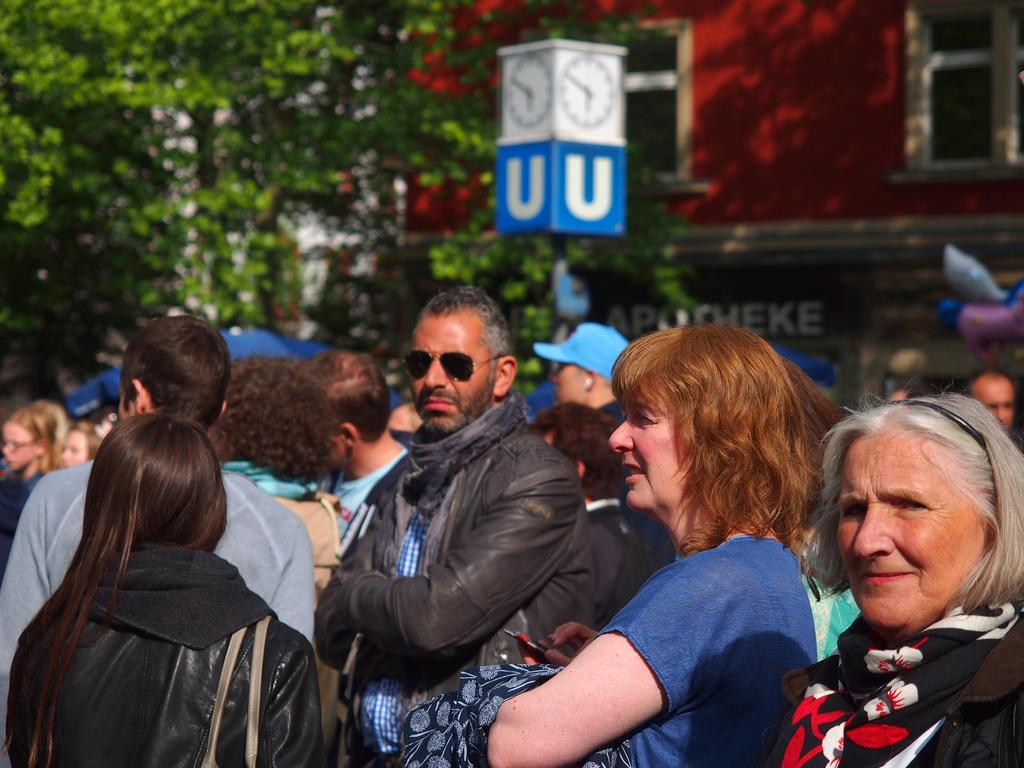What type of clothing item can be seen in the image? There is a bag, a scarf, a jacket, goggles, and a cap visible in the image. What accessory is present in the image? Goggles are present in the image. What type of headwear is in the image? There is a cap in the image. What objects are in the background of the image? There are trees and a building with windows in the background of the image. What structure is visible in the image? There is a pole in the image. What else can be seen in the image? There are clocks in the image. How many people are in the image? There is a group of people standing in the image. What type of vest can be seen on the trees in the background of the image? There are no vests present on the trees in the background of the image. What type of sail is visible on the building in the background of the image? There are no sails visible on the building in the background of the image. 